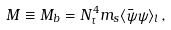Convert formula to latex. <formula><loc_0><loc_0><loc_500><loc_500>M \equiv M _ { b } = N _ { \tau } ^ { 4 } m _ { s } \langle \bar { \psi } \psi \rangle _ { l } \, ,</formula> 